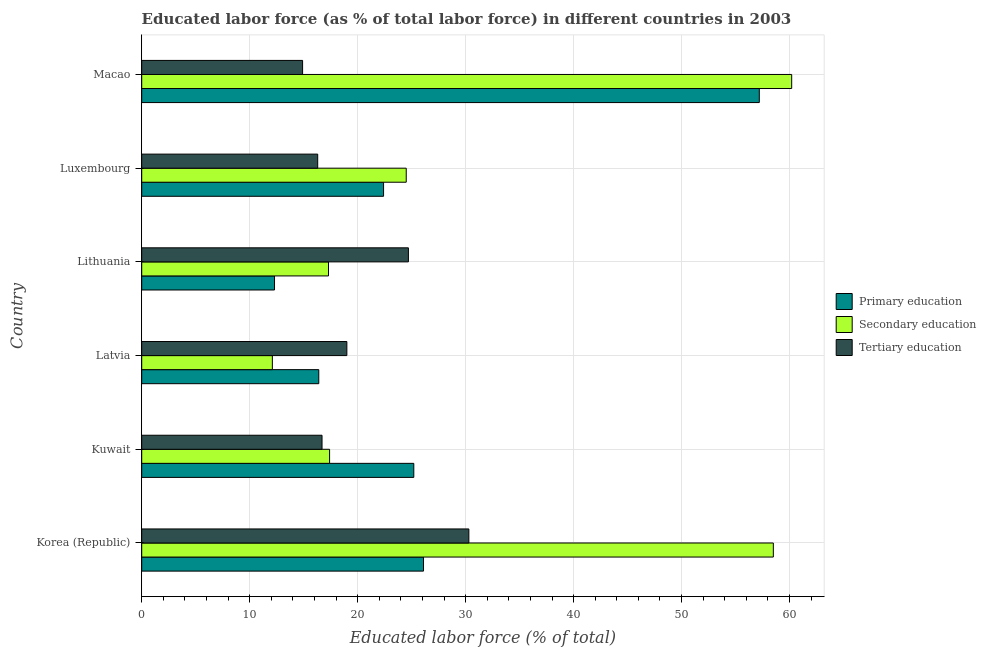Are the number of bars per tick equal to the number of legend labels?
Give a very brief answer. Yes. Are the number of bars on each tick of the Y-axis equal?
Offer a terse response. Yes. How many bars are there on the 3rd tick from the top?
Offer a terse response. 3. What is the label of the 1st group of bars from the top?
Ensure brevity in your answer.  Macao. In how many cases, is the number of bars for a given country not equal to the number of legend labels?
Give a very brief answer. 0. What is the percentage of labor force who received primary education in Macao?
Give a very brief answer. 57.2. Across all countries, what is the maximum percentage of labor force who received secondary education?
Ensure brevity in your answer.  60.2. Across all countries, what is the minimum percentage of labor force who received secondary education?
Your answer should be compact. 12.1. In which country was the percentage of labor force who received tertiary education maximum?
Make the answer very short. Korea (Republic). In which country was the percentage of labor force who received tertiary education minimum?
Keep it short and to the point. Macao. What is the total percentage of labor force who received tertiary education in the graph?
Your response must be concise. 121.9. What is the difference between the percentage of labor force who received primary education in Lithuania and that in Luxembourg?
Give a very brief answer. -10.1. What is the average percentage of labor force who received secondary education per country?
Provide a succinct answer. 31.67. What is the ratio of the percentage of labor force who received secondary education in Luxembourg to that in Macao?
Your answer should be very brief. 0.41. Is the percentage of labor force who received primary education in Kuwait less than that in Lithuania?
Your answer should be compact. No. What is the difference between the highest and the lowest percentage of labor force who received tertiary education?
Keep it short and to the point. 15.4. How many bars are there?
Offer a very short reply. 18. Are all the bars in the graph horizontal?
Your answer should be compact. Yes. What is the difference between two consecutive major ticks on the X-axis?
Provide a succinct answer. 10. Are the values on the major ticks of X-axis written in scientific E-notation?
Keep it short and to the point. No. Does the graph contain any zero values?
Offer a very short reply. No. How many legend labels are there?
Offer a very short reply. 3. What is the title of the graph?
Your answer should be compact. Educated labor force (as % of total labor force) in different countries in 2003. What is the label or title of the X-axis?
Your answer should be compact. Educated labor force (% of total). What is the Educated labor force (% of total) of Primary education in Korea (Republic)?
Your answer should be compact. 26.1. What is the Educated labor force (% of total) of Secondary education in Korea (Republic)?
Keep it short and to the point. 58.5. What is the Educated labor force (% of total) of Tertiary education in Korea (Republic)?
Provide a succinct answer. 30.3. What is the Educated labor force (% of total) of Primary education in Kuwait?
Offer a very short reply. 25.2. What is the Educated labor force (% of total) in Secondary education in Kuwait?
Provide a short and direct response. 17.4. What is the Educated labor force (% of total) of Tertiary education in Kuwait?
Provide a succinct answer. 16.7. What is the Educated labor force (% of total) of Primary education in Latvia?
Offer a very short reply. 16.4. What is the Educated labor force (% of total) of Secondary education in Latvia?
Keep it short and to the point. 12.1. What is the Educated labor force (% of total) in Tertiary education in Latvia?
Your answer should be compact. 19. What is the Educated labor force (% of total) of Primary education in Lithuania?
Offer a terse response. 12.3. What is the Educated labor force (% of total) of Secondary education in Lithuania?
Your response must be concise. 17.3. What is the Educated labor force (% of total) in Tertiary education in Lithuania?
Make the answer very short. 24.7. What is the Educated labor force (% of total) of Primary education in Luxembourg?
Your answer should be compact. 22.4. What is the Educated labor force (% of total) of Tertiary education in Luxembourg?
Your response must be concise. 16.3. What is the Educated labor force (% of total) of Primary education in Macao?
Your response must be concise. 57.2. What is the Educated labor force (% of total) of Secondary education in Macao?
Ensure brevity in your answer.  60.2. What is the Educated labor force (% of total) in Tertiary education in Macao?
Offer a terse response. 14.9. Across all countries, what is the maximum Educated labor force (% of total) in Primary education?
Offer a terse response. 57.2. Across all countries, what is the maximum Educated labor force (% of total) in Secondary education?
Give a very brief answer. 60.2. Across all countries, what is the maximum Educated labor force (% of total) in Tertiary education?
Give a very brief answer. 30.3. Across all countries, what is the minimum Educated labor force (% of total) in Primary education?
Keep it short and to the point. 12.3. Across all countries, what is the minimum Educated labor force (% of total) in Secondary education?
Keep it short and to the point. 12.1. Across all countries, what is the minimum Educated labor force (% of total) in Tertiary education?
Your answer should be very brief. 14.9. What is the total Educated labor force (% of total) in Primary education in the graph?
Your answer should be compact. 159.6. What is the total Educated labor force (% of total) in Secondary education in the graph?
Ensure brevity in your answer.  190. What is the total Educated labor force (% of total) in Tertiary education in the graph?
Offer a terse response. 121.9. What is the difference between the Educated labor force (% of total) of Primary education in Korea (Republic) and that in Kuwait?
Your response must be concise. 0.9. What is the difference between the Educated labor force (% of total) in Secondary education in Korea (Republic) and that in Kuwait?
Offer a terse response. 41.1. What is the difference between the Educated labor force (% of total) of Tertiary education in Korea (Republic) and that in Kuwait?
Your response must be concise. 13.6. What is the difference between the Educated labor force (% of total) of Primary education in Korea (Republic) and that in Latvia?
Give a very brief answer. 9.7. What is the difference between the Educated labor force (% of total) in Secondary education in Korea (Republic) and that in Latvia?
Your answer should be compact. 46.4. What is the difference between the Educated labor force (% of total) in Tertiary education in Korea (Republic) and that in Latvia?
Ensure brevity in your answer.  11.3. What is the difference between the Educated labor force (% of total) of Primary education in Korea (Republic) and that in Lithuania?
Keep it short and to the point. 13.8. What is the difference between the Educated labor force (% of total) in Secondary education in Korea (Republic) and that in Lithuania?
Your response must be concise. 41.2. What is the difference between the Educated labor force (% of total) of Tertiary education in Korea (Republic) and that in Lithuania?
Give a very brief answer. 5.6. What is the difference between the Educated labor force (% of total) of Secondary education in Korea (Republic) and that in Luxembourg?
Your response must be concise. 34. What is the difference between the Educated labor force (% of total) in Primary education in Korea (Republic) and that in Macao?
Offer a terse response. -31.1. What is the difference between the Educated labor force (% of total) in Tertiary education in Kuwait and that in Lithuania?
Make the answer very short. -8. What is the difference between the Educated labor force (% of total) of Secondary education in Kuwait and that in Luxembourg?
Your response must be concise. -7.1. What is the difference between the Educated labor force (% of total) in Primary education in Kuwait and that in Macao?
Keep it short and to the point. -32. What is the difference between the Educated labor force (% of total) of Secondary education in Kuwait and that in Macao?
Ensure brevity in your answer.  -42.8. What is the difference between the Educated labor force (% of total) of Tertiary education in Kuwait and that in Macao?
Make the answer very short. 1.8. What is the difference between the Educated labor force (% of total) of Secondary education in Latvia and that in Lithuania?
Give a very brief answer. -5.2. What is the difference between the Educated labor force (% of total) in Primary education in Latvia and that in Luxembourg?
Offer a terse response. -6. What is the difference between the Educated labor force (% of total) in Primary education in Latvia and that in Macao?
Ensure brevity in your answer.  -40.8. What is the difference between the Educated labor force (% of total) in Secondary education in Latvia and that in Macao?
Your answer should be compact. -48.1. What is the difference between the Educated labor force (% of total) of Tertiary education in Latvia and that in Macao?
Your response must be concise. 4.1. What is the difference between the Educated labor force (% of total) in Secondary education in Lithuania and that in Luxembourg?
Provide a short and direct response. -7.2. What is the difference between the Educated labor force (% of total) of Primary education in Lithuania and that in Macao?
Your response must be concise. -44.9. What is the difference between the Educated labor force (% of total) of Secondary education in Lithuania and that in Macao?
Keep it short and to the point. -42.9. What is the difference between the Educated labor force (% of total) in Tertiary education in Lithuania and that in Macao?
Provide a succinct answer. 9.8. What is the difference between the Educated labor force (% of total) of Primary education in Luxembourg and that in Macao?
Provide a short and direct response. -34.8. What is the difference between the Educated labor force (% of total) in Secondary education in Luxembourg and that in Macao?
Provide a short and direct response. -35.7. What is the difference between the Educated labor force (% of total) of Tertiary education in Luxembourg and that in Macao?
Keep it short and to the point. 1.4. What is the difference between the Educated labor force (% of total) in Primary education in Korea (Republic) and the Educated labor force (% of total) in Secondary education in Kuwait?
Offer a very short reply. 8.7. What is the difference between the Educated labor force (% of total) in Secondary education in Korea (Republic) and the Educated labor force (% of total) in Tertiary education in Kuwait?
Provide a short and direct response. 41.8. What is the difference between the Educated labor force (% of total) in Secondary education in Korea (Republic) and the Educated labor force (% of total) in Tertiary education in Latvia?
Your response must be concise. 39.5. What is the difference between the Educated labor force (% of total) in Primary education in Korea (Republic) and the Educated labor force (% of total) in Secondary education in Lithuania?
Ensure brevity in your answer.  8.8. What is the difference between the Educated labor force (% of total) in Secondary education in Korea (Republic) and the Educated labor force (% of total) in Tertiary education in Lithuania?
Provide a short and direct response. 33.8. What is the difference between the Educated labor force (% of total) in Primary education in Korea (Republic) and the Educated labor force (% of total) in Secondary education in Luxembourg?
Your answer should be compact. 1.6. What is the difference between the Educated labor force (% of total) of Secondary education in Korea (Republic) and the Educated labor force (% of total) of Tertiary education in Luxembourg?
Make the answer very short. 42.2. What is the difference between the Educated labor force (% of total) in Primary education in Korea (Republic) and the Educated labor force (% of total) in Secondary education in Macao?
Offer a very short reply. -34.1. What is the difference between the Educated labor force (% of total) of Primary education in Korea (Republic) and the Educated labor force (% of total) of Tertiary education in Macao?
Ensure brevity in your answer.  11.2. What is the difference between the Educated labor force (% of total) in Secondary education in Korea (Republic) and the Educated labor force (% of total) in Tertiary education in Macao?
Provide a succinct answer. 43.6. What is the difference between the Educated labor force (% of total) in Primary education in Kuwait and the Educated labor force (% of total) in Secondary education in Latvia?
Offer a terse response. 13.1. What is the difference between the Educated labor force (% of total) of Primary education in Kuwait and the Educated labor force (% of total) of Tertiary education in Latvia?
Your answer should be very brief. 6.2. What is the difference between the Educated labor force (% of total) in Primary education in Kuwait and the Educated labor force (% of total) in Secondary education in Macao?
Make the answer very short. -35. What is the difference between the Educated labor force (% of total) in Primary education in Kuwait and the Educated labor force (% of total) in Tertiary education in Macao?
Make the answer very short. 10.3. What is the difference between the Educated labor force (% of total) in Primary education in Latvia and the Educated labor force (% of total) in Secondary education in Lithuania?
Provide a short and direct response. -0.9. What is the difference between the Educated labor force (% of total) in Primary education in Latvia and the Educated labor force (% of total) in Tertiary education in Luxembourg?
Provide a short and direct response. 0.1. What is the difference between the Educated labor force (% of total) in Secondary education in Latvia and the Educated labor force (% of total) in Tertiary education in Luxembourg?
Make the answer very short. -4.2. What is the difference between the Educated labor force (% of total) of Primary education in Latvia and the Educated labor force (% of total) of Secondary education in Macao?
Your answer should be very brief. -43.8. What is the difference between the Educated labor force (% of total) in Primary education in Lithuania and the Educated labor force (% of total) in Secondary education in Luxembourg?
Provide a succinct answer. -12.2. What is the difference between the Educated labor force (% of total) of Primary education in Lithuania and the Educated labor force (% of total) of Secondary education in Macao?
Ensure brevity in your answer.  -47.9. What is the difference between the Educated labor force (% of total) of Primary education in Luxembourg and the Educated labor force (% of total) of Secondary education in Macao?
Provide a succinct answer. -37.8. What is the difference between the Educated labor force (% of total) in Primary education in Luxembourg and the Educated labor force (% of total) in Tertiary education in Macao?
Your answer should be compact. 7.5. What is the average Educated labor force (% of total) in Primary education per country?
Ensure brevity in your answer.  26.6. What is the average Educated labor force (% of total) of Secondary education per country?
Your answer should be compact. 31.67. What is the average Educated labor force (% of total) of Tertiary education per country?
Ensure brevity in your answer.  20.32. What is the difference between the Educated labor force (% of total) of Primary education and Educated labor force (% of total) of Secondary education in Korea (Republic)?
Ensure brevity in your answer.  -32.4. What is the difference between the Educated labor force (% of total) in Secondary education and Educated labor force (% of total) in Tertiary education in Korea (Republic)?
Provide a short and direct response. 28.2. What is the difference between the Educated labor force (% of total) in Primary education and Educated labor force (% of total) in Secondary education in Kuwait?
Ensure brevity in your answer.  7.8. What is the difference between the Educated labor force (% of total) in Primary education and Educated labor force (% of total) in Tertiary education in Latvia?
Your response must be concise. -2.6. What is the difference between the Educated labor force (% of total) of Primary education and Educated labor force (% of total) of Tertiary education in Luxembourg?
Offer a terse response. 6.1. What is the difference between the Educated labor force (% of total) of Primary education and Educated labor force (% of total) of Tertiary education in Macao?
Keep it short and to the point. 42.3. What is the difference between the Educated labor force (% of total) of Secondary education and Educated labor force (% of total) of Tertiary education in Macao?
Ensure brevity in your answer.  45.3. What is the ratio of the Educated labor force (% of total) of Primary education in Korea (Republic) to that in Kuwait?
Offer a terse response. 1.04. What is the ratio of the Educated labor force (% of total) in Secondary education in Korea (Republic) to that in Kuwait?
Make the answer very short. 3.36. What is the ratio of the Educated labor force (% of total) of Tertiary education in Korea (Republic) to that in Kuwait?
Keep it short and to the point. 1.81. What is the ratio of the Educated labor force (% of total) of Primary education in Korea (Republic) to that in Latvia?
Give a very brief answer. 1.59. What is the ratio of the Educated labor force (% of total) in Secondary education in Korea (Republic) to that in Latvia?
Make the answer very short. 4.83. What is the ratio of the Educated labor force (% of total) in Tertiary education in Korea (Republic) to that in Latvia?
Ensure brevity in your answer.  1.59. What is the ratio of the Educated labor force (% of total) of Primary education in Korea (Republic) to that in Lithuania?
Offer a terse response. 2.12. What is the ratio of the Educated labor force (% of total) of Secondary education in Korea (Republic) to that in Lithuania?
Your answer should be very brief. 3.38. What is the ratio of the Educated labor force (% of total) of Tertiary education in Korea (Republic) to that in Lithuania?
Provide a succinct answer. 1.23. What is the ratio of the Educated labor force (% of total) in Primary education in Korea (Republic) to that in Luxembourg?
Make the answer very short. 1.17. What is the ratio of the Educated labor force (% of total) in Secondary education in Korea (Republic) to that in Luxembourg?
Your response must be concise. 2.39. What is the ratio of the Educated labor force (% of total) in Tertiary education in Korea (Republic) to that in Luxembourg?
Your answer should be compact. 1.86. What is the ratio of the Educated labor force (% of total) in Primary education in Korea (Republic) to that in Macao?
Offer a terse response. 0.46. What is the ratio of the Educated labor force (% of total) of Secondary education in Korea (Republic) to that in Macao?
Make the answer very short. 0.97. What is the ratio of the Educated labor force (% of total) of Tertiary education in Korea (Republic) to that in Macao?
Your answer should be compact. 2.03. What is the ratio of the Educated labor force (% of total) of Primary education in Kuwait to that in Latvia?
Your answer should be compact. 1.54. What is the ratio of the Educated labor force (% of total) in Secondary education in Kuwait to that in Latvia?
Keep it short and to the point. 1.44. What is the ratio of the Educated labor force (% of total) in Tertiary education in Kuwait to that in Latvia?
Ensure brevity in your answer.  0.88. What is the ratio of the Educated labor force (% of total) of Primary education in Kuwait to that in Lithuania?
Offer a terse response. 2.05. What is the ratio of the Educated labor force (% of total) in Tertiary education in Kuwait to that in Lithuania?
Your response must be concise. 0.68. What is the ratio of the Educated labor force (% of total) in Primary education in Kuwait to that in Luxembourg?
Give a very brief answer. 1.12. What is the ratio of the Educated labor force (% of total) in Secondary education in Kuwait to that in Luxembourg?
Provide a succinct answer. 0.71. What is the ratio of the Educated labor force (% of total) of Tertiary education in Kuwait to that in Luxembourg?
Provide a succinct answer. 1.02. What is the ratio of the Educated labor force (% of total) of Primary education in Kuwait to that in Macao?
Keep it short and to the point. 0.44. What is the ratio of the Educated labor force (% of total) in Secondary education in Kuwait to that in Macao?
Offer a very short reply. 0.29. What is the ratio of the Educated labor force (% of total) in Tertiary education in Kuwait to that in Macao?
Ensure brevity in your answer.  1.12. What is the ratio of the Educated labor force (% of total) in Primary education in Latvia to that in Lithuania?
Offer a terse response. 1.33. What is the ratio of the Educated labor force (% of total) in Secondary education in Latvia to that in Lithuania?
Provide a short and direct response. 0.7. What is the ratio of the Educated labor force (% of total) of Tertiary education in Latvia to that in Lithuania?
Your response must be concise. 0.77. What is the ratio of the Educated labor force (% of total) of Primary education in Latvia to that in Luxembourg?
Make the answer very short. 0.73. What is the ratio of the Educated labor force (% of total) of Secondary education in Latvia to that in Luxembourg?
Provide a succinct answer. 0.49. What is the ratio of the Educated labor force (% of total) in Tertiary education in Latvia to that in Luxembourg?
Make the answer very short. 1.17. What is the ratio of the Educated labor force (% of total) in Primary education in Latvia to that in Macao?
Provide a succinct answer. 0.29. What is the ratio of the Educated labor force (% of total) of Secondary education in Latvia to that in Macao?
Provide a succinct answer. 0.2. What is the ratio of the Educated labor force (% of total) in Tertiary education in Latvia to that in Macao?
Ensure brevity in your answer.  1.28. What is the ratio of the Educated labor force (% of total) in Primary education in Lithuania to that in Luxembourg?
Ensure brevity in your answer.  0.55. What is the ratio of the Educated labor force (% of total) of Secondary education in Lithuania to that in Luxembourg?
Offer a terse response. 0.71. What is the ratio of the Educated labor force (% of total) of Tertiary education in Lithuania to that in Luxembourg?
Provide a short and direct response. 1.52. What is the ratio of the Educated labor force (% of total) in Primary education in Lithuania to that in Macao?
Ensure brevity in your answer.  0.21. What is the ratio of the Educated labor force (% of total) in Secondary education in Lithuania to that in Macao?
Give a very brief answer. 0.29. What is the ratio of the Educated labor force (% of total) in Tertiary education in Lithuania to that in Macao?
Provide a succinct answer. 1.66. What is the ratio of the Educated labor force (% of total) in Primary education in Luxembourg to that in Macao?
Offer a very short reply. 0.39. What is the ratio of the Educated labor force (% of total) in Secondary education in Luxembourg to that in Macao?
Offer a very short reply. 0.41. What is the ratio of the Educated labor force (% of total) of Tertiary education in Luxembourg to that in Macao?
Ensure brevity in your answer.  1.09. What is the difference between the highest and the second highest Educated labor force (% of total) in Primary education?
Your answer should be very brief. 31.1. What is the difference between the highest and the lowest Educated labor force (% of total) in Primary education?
Make the answer very short. 44.9. What is the difference between the highest and the lowest Educated labor force (% of total) in Secondary education?
Offer a very short reply. 48.1. What is the difference between the highest and the lowest Educated labor force (% of total) of Tertiary education?
Provide a succinct answer. 15.4. 